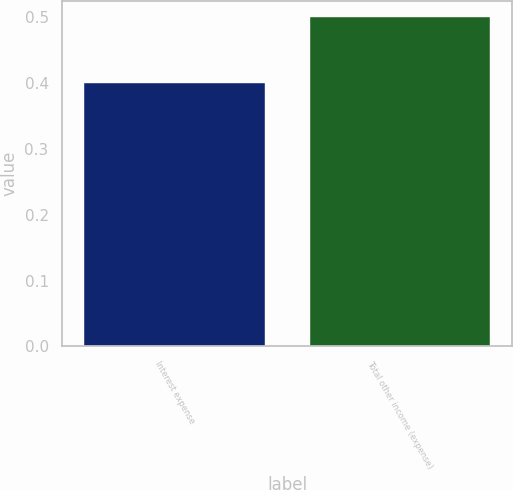Convert chart to OTSL. <chart><loc_0><loc_0><loc_500><loc_500><bar_chart><fcel>Interest expense<fcel>Total other income (expense)<nl><fcel>0.4<fcel>0.5<nl></chart> 